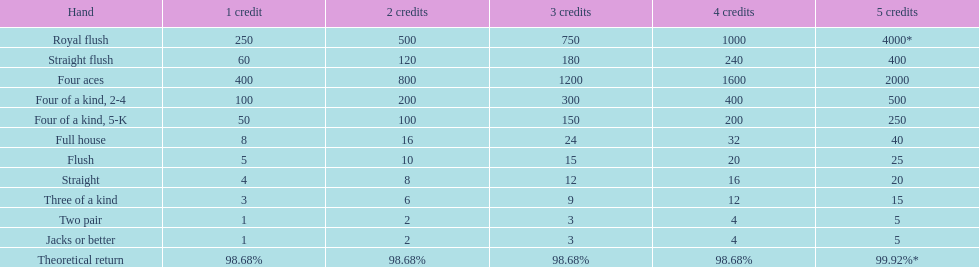What is the payout for achieving a full house and winning on four credits? 32. 